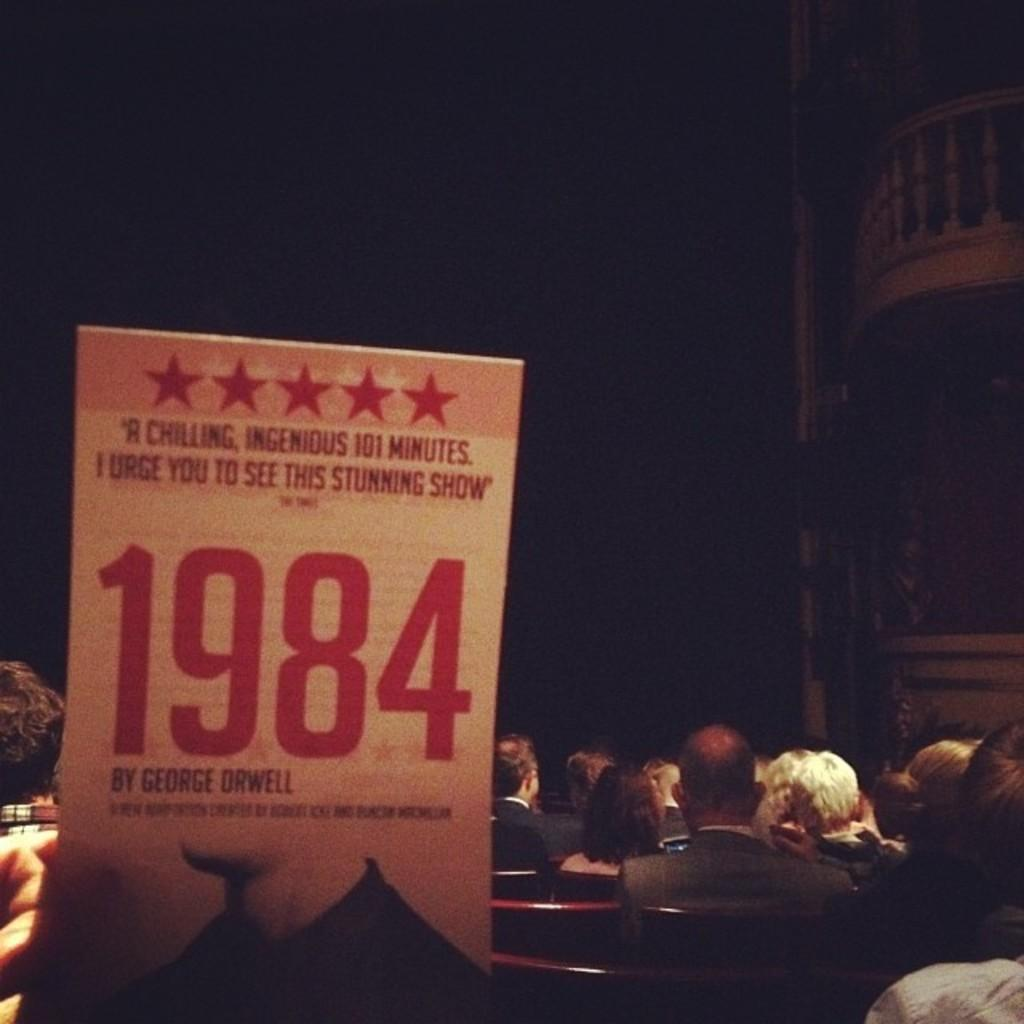What are the people in the image doing? The people in the image are sitting on chairs. What can be seen on the left side of the image? There is a board on the left side of the image. How many pets are participating in the competition in the image? There is no competition or pets present in the image. 